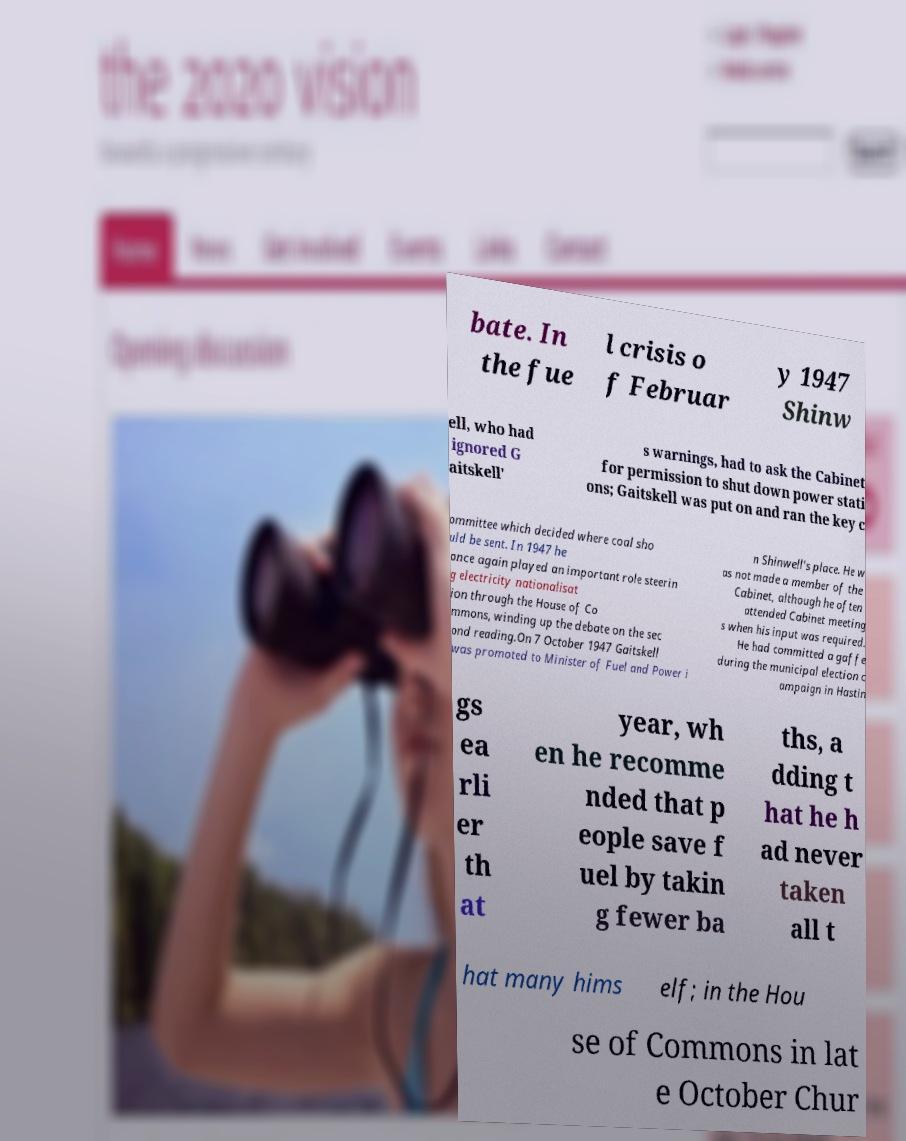Can you read and provide the text displayed in the image?This photo seems to have some interesting text. Can you extract and type it out for me? bate. In the fue l crisis o f Februar y 1947 Shinw ell, who had ignored G aitskell' s warnings, had to ask the Cabinet for permission to shut down power stati ons; Gaitskell was put on and ran the key c ommittee which decided where coal sho uld be sent. In 1947 he once again played an important role steerin g electricity nationalisat ion through the House of Co mmons, winding up the debate on the sec ond reading.On 7 October 1947 Gaitskell was promoted to Minister of Fuel and Power i n Shinwell's place. He w as not made a member of the Cabinet, although he often attended Cabinet meeting s when his input was required. He had committed a gaffe during the municipal election c ampaign in Hastin gs ea rli er th at year, wh en he recomme nded that p eople save f uel by takin g fewer ba ths, a dding t hat he h ad never taken all t hat many hims elf; in the Hou se of Commons in lat e October Chur 